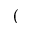<formula> <loc_0><loc_0><loc_500><loc_500>(</formula> 